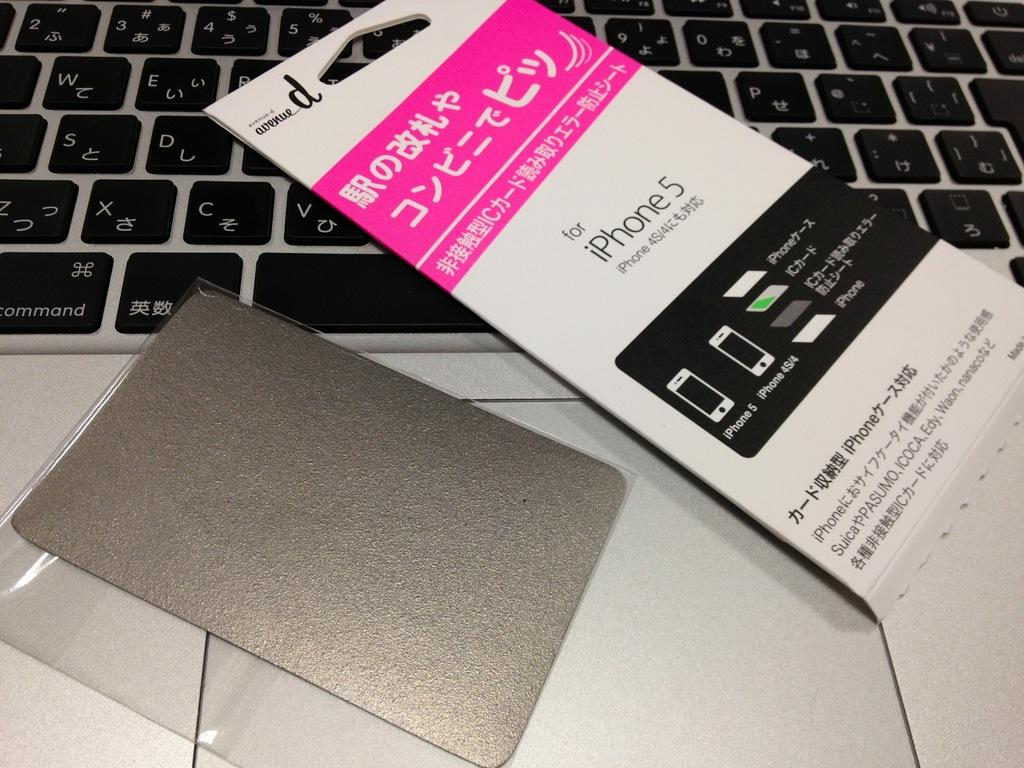<image>
Share a concise interpretation of the image provided. The avenue_d accessory is specifically for iPhone 5, iPhone 4S/4. 